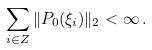Convert formula to latex. <formula><loc_0><loc_0><loc_500><loc_500>\sum _ { i \in { Z } } \| P _ { 0 } ( \xi _ { i } ) \| _ { 2 } < \infty \, .</formula> 